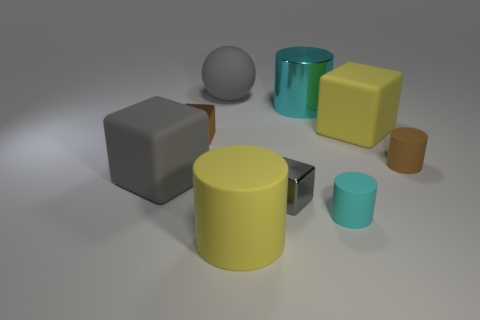What material is the big ball?
Your answer should be very brief. Rubber. Are any cylinders visible?
Your answer should be very brief. Yes. What is the color of the big matte cube that is to the left of the big ball?
Your answer should be compact. Gray. How many things are in front of the big cylinder behind the big cylinder in front of the brown block?
Offer a terse response. 7. There is a big thing that is behind the large yellow rubber cube and in front of the gray ball; what material is it?
Offer a very short reply. Metal. Does the brown block have the same material as the tiny brown object that is to the right of the big gray rubber ball?
Ensure brevity in your answer.  No. Are there more tiny gray shiny cubes that are behind the big yellow rubber cube than tiny brown cubes that are behind the big yellow cylinder?
Provide a succinct answer. No. The cyan metallic object is what shape?
Give a very brief answer. Cylinder. Are the large gray object that is behind the brown metallic object and the large object right of the large cyan object made of the same material?
Provide a succinct answer. Yes. What is the shape of the big gray thing behind the brown rubber thing?
Ensure brevity in your answer.  Sphere. 